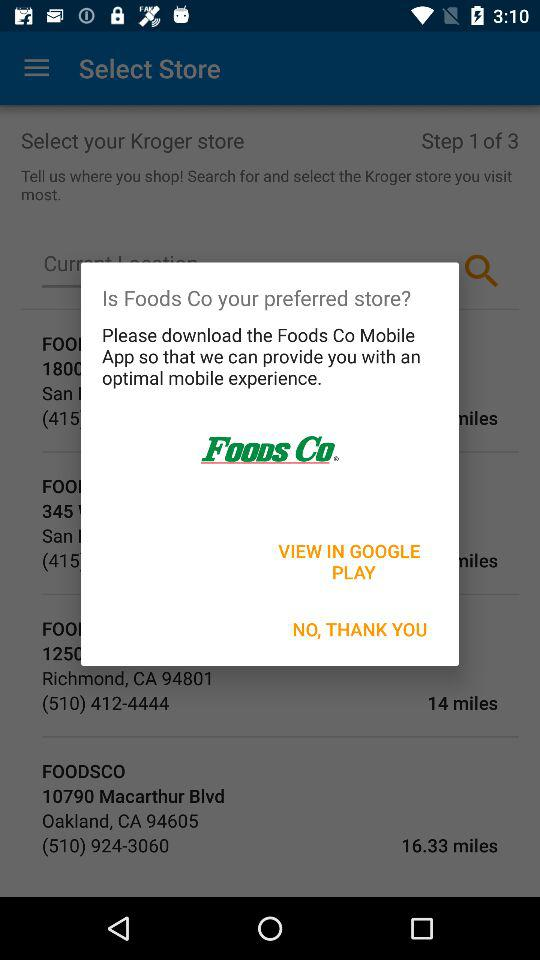What is the application name? The application name is "Foods Co". 